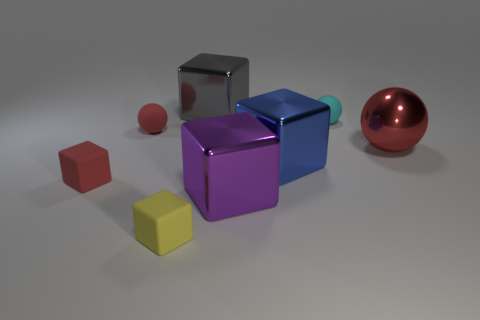Subtract all blue cylinders. How many red spheres are left? 2 Subtract all big blue metallic blocks. How many blocks are left? 4 Add 1 tiny matte blocks. How many objects exist? 9 Subtract all blue cubes. How many cubes are left? 4 Add 2 tiny blocks. How many tiny blocks exist? 4 Subtract 0 cyan cylinders. How many objects are left? 8 Subtract all cubes. How many objects are left? 3 Subtract all blue cubes. Subtract all yellow cylinders. How many cubes are left? 4 Subtract all balls. Subtract all big purple metallic cubes. How many objects are left? 4 Add 7 small cyan matte things. How many small cyan matte things are left? 8 